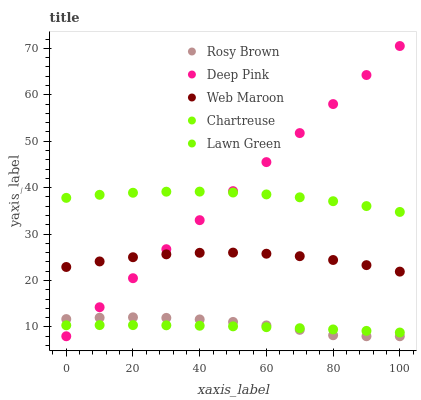Does Lawn Green have the minimum area under the curve?
Answer yes or no. Yes. Does Deep Pink have the maximum area under the curve?
Answer yes or no. Yes. Does Chartreuse have the minimum area under the curve?
Answer yes or no. No. Does Chartreuse have the maximum area under the curve?
Answer yes or no. No. Is Deep Pink the smoothest?
Answer yes or no. Yes. Is Rosy Brown the roughest?
Answer yes or no. Yes. Is Chartreuse the smoothest?
Answer yes or no. No. Is Chartreuse the roughest?
Answer yes or no. No. Does Rosy Brown have the lowest value?
Answer yes or no. Yes. Does Chartreuse have the lowest value?
Answer yes or no. No. Does Deep Pink have the highest value?
Answer yes or no. Yes. Does Chartreuse have the highest value?
Answer yes or no. No. Is Web Maroon less than Chartreuse?
Answer yes or no. Yes. Is Chartreuse greater than Lawn Green?
Answer yes or no. Yes. Does Lawn Green intersect Rosy Brown?
Answer yes or no. Yes. Is Lawn Green less than Rosy Brown?
Answer yes or no. No. Is Lawn Green greater than Rosy Brown?
Answer yes or no. No. Does Web Maroon intersect Chartreuse?
Answer yes or no. No. 